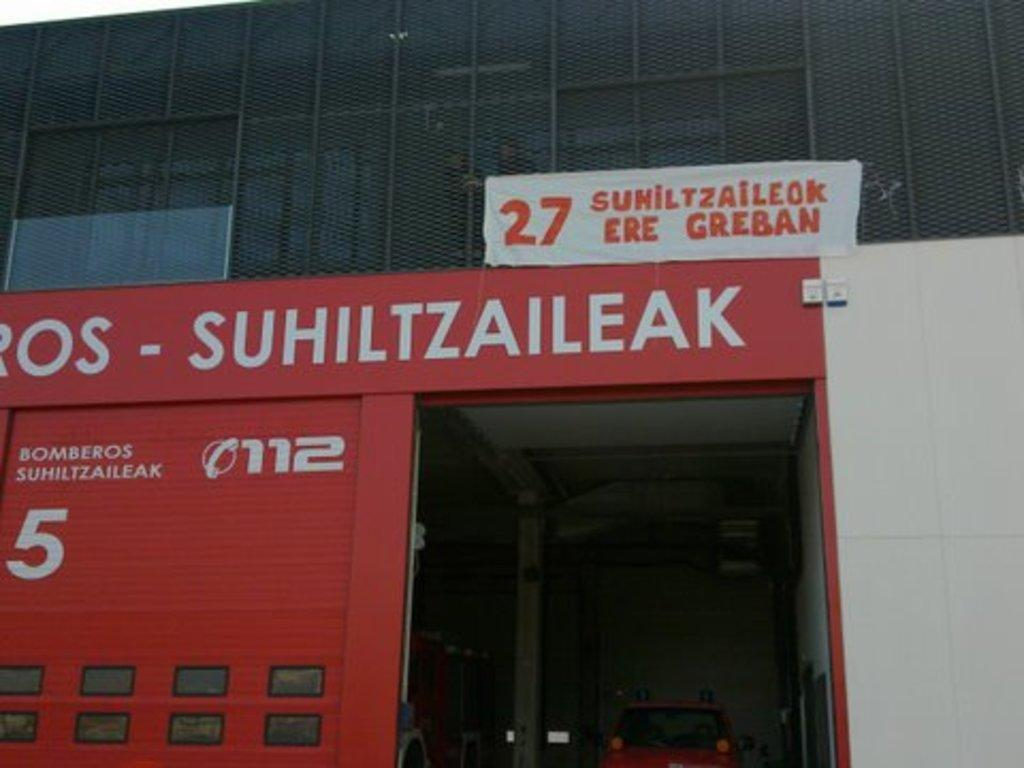What type of structure is visible in the image? There is a building in the image. What is attached to the building? There is a banner on the building. What type of cooking equipment can be seen in the image? There are grills in the image. Can you describe any other objects or features in the image? There are other unspecified things in the image. What type of stem is being used to hold the banner in the image? There is no stem visible in the image; the banner is attached to the building. Can you describe the haircut of the person holding the grills in the image? There are no people present in the image, so it is not possible to describe anyone's haircut. 